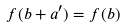Convert formula to latex. <formula><loc_0><loc_0><loc_500><loc_500>f ( b + a ^ { \prime } ) = f ( b )</formula> 